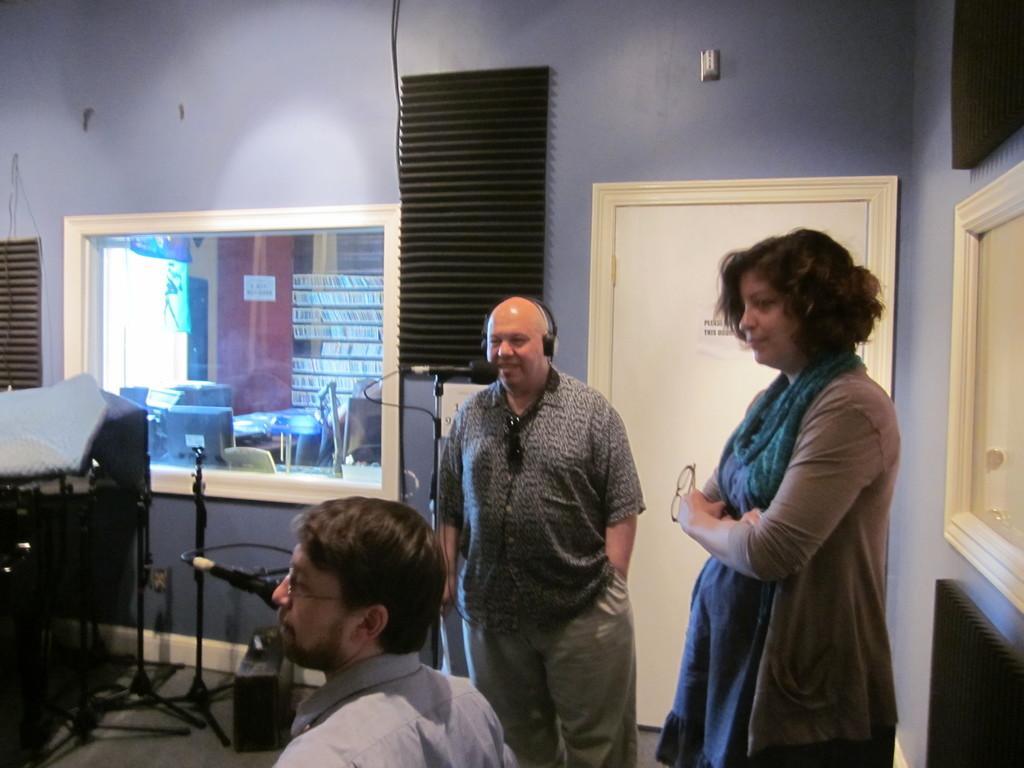Please provide a concise description of this image. In this image there are objects on the wall in the right corner. There are objects, there is a glass in which we can see monitors, there is an object on the wall in the left corner. There are people, mikes, there is a door. There is an object on the wall in the background. 